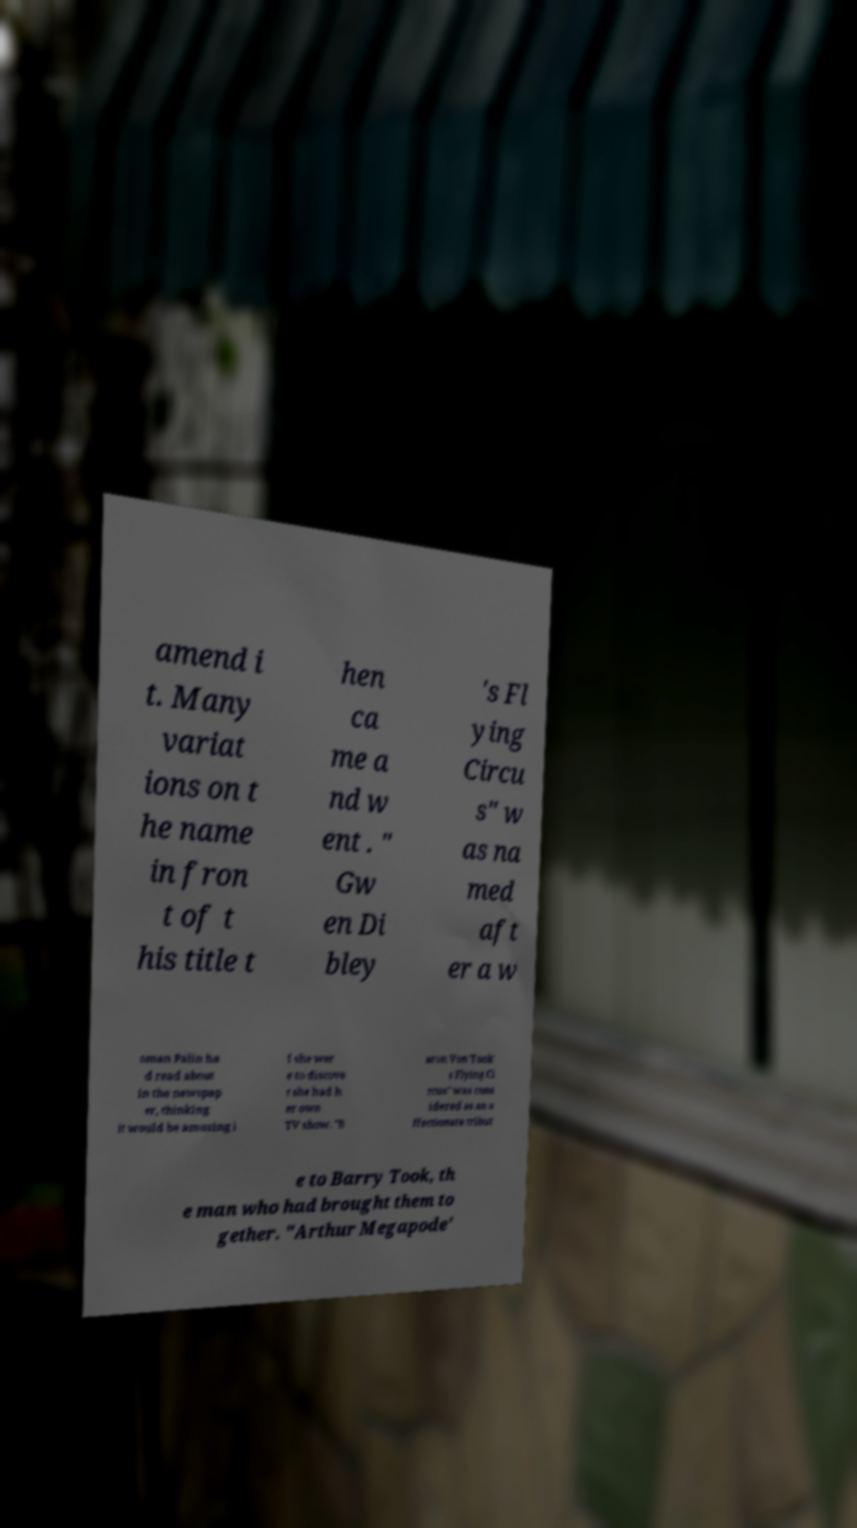Can you read and provide the text displayed in the image?This photo seems to have some interesting text. Can you extract and type it out for me? amend i t. Many variat ions on t he name in fron t of t his title t hen ca me a nd w ent . " Gw en Di bley 's Fl ying Circu s" w as na med aft er a w oman Palin ha d read about in the newspap er, thinking it would be amusing i f she wer e to discove r she had h er own TV show. "B aron Von Took' s Flying Ci rcus" was cons idered as an a ffectionate tribut e to Barry Took, th e man who had brought them to gether. "Arthur Megapode' 